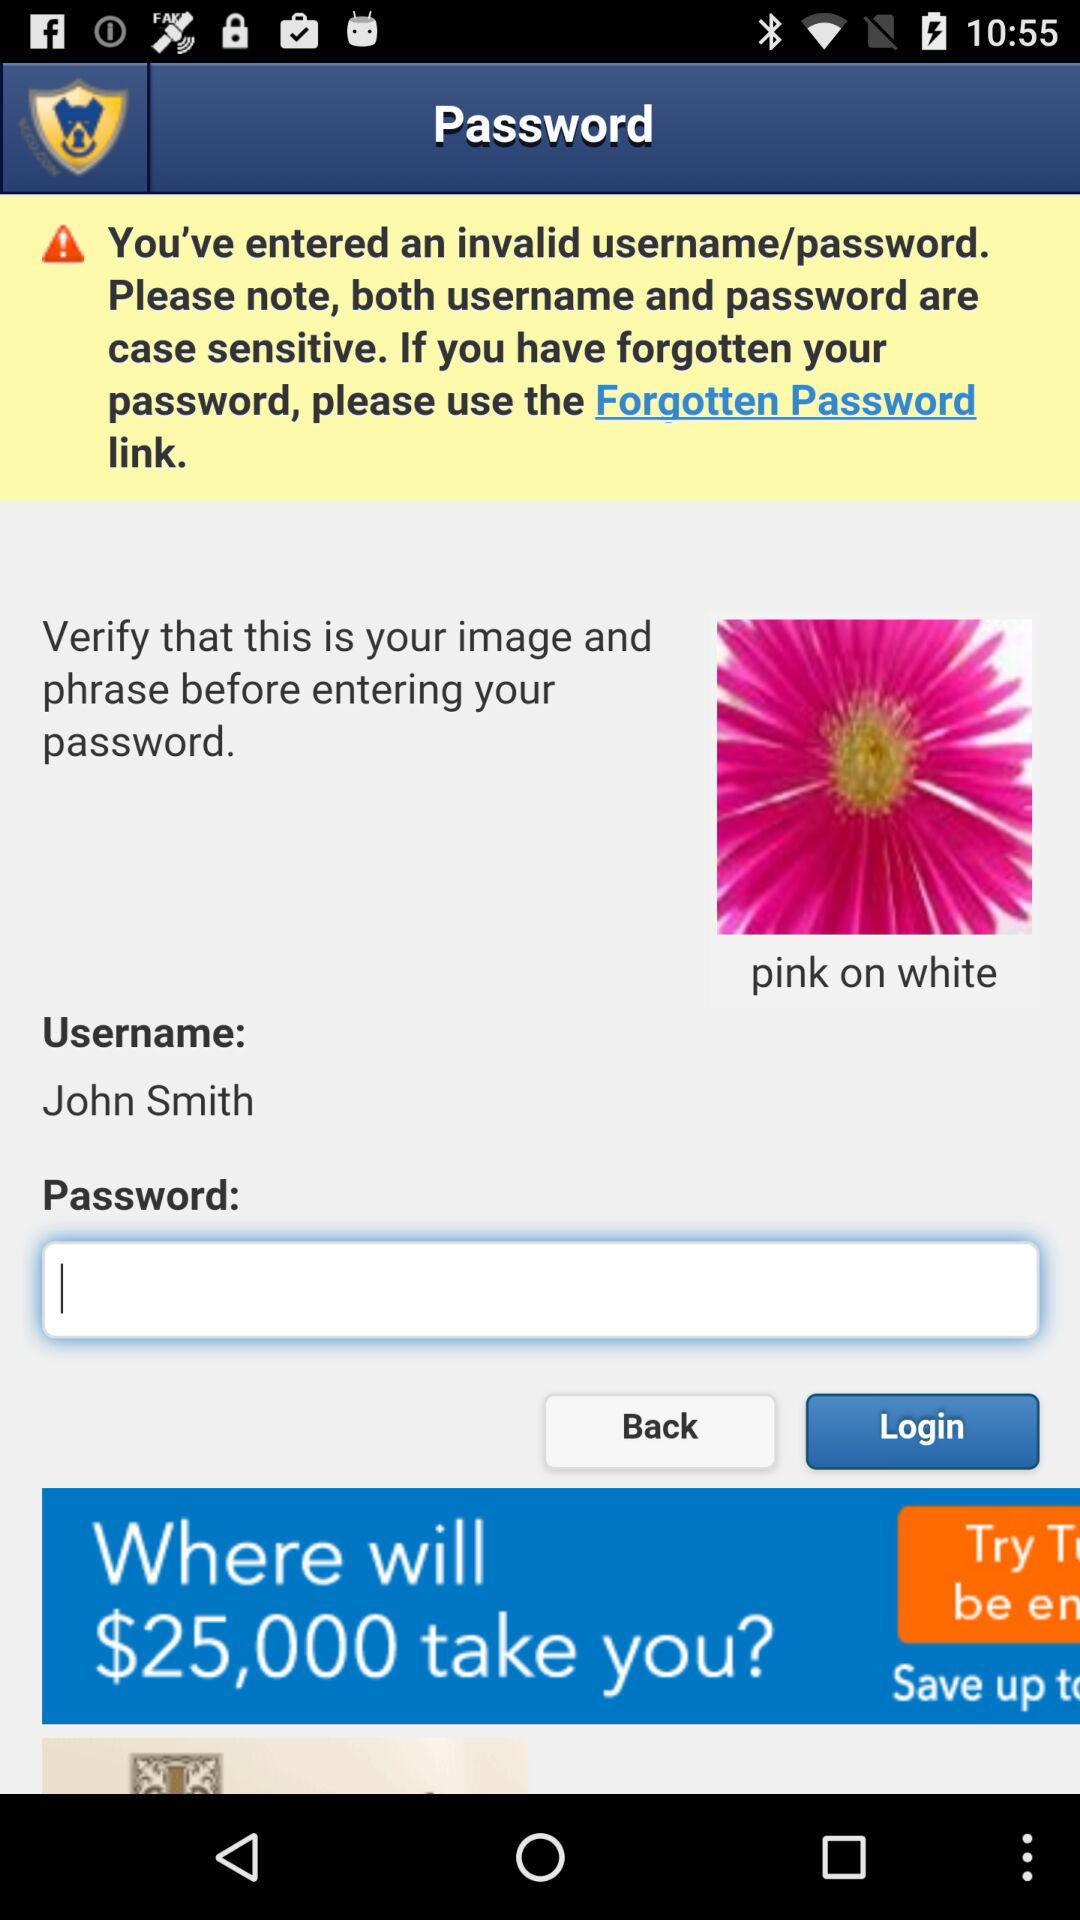How can we log in? You can log in with the "Username" and "Password". 